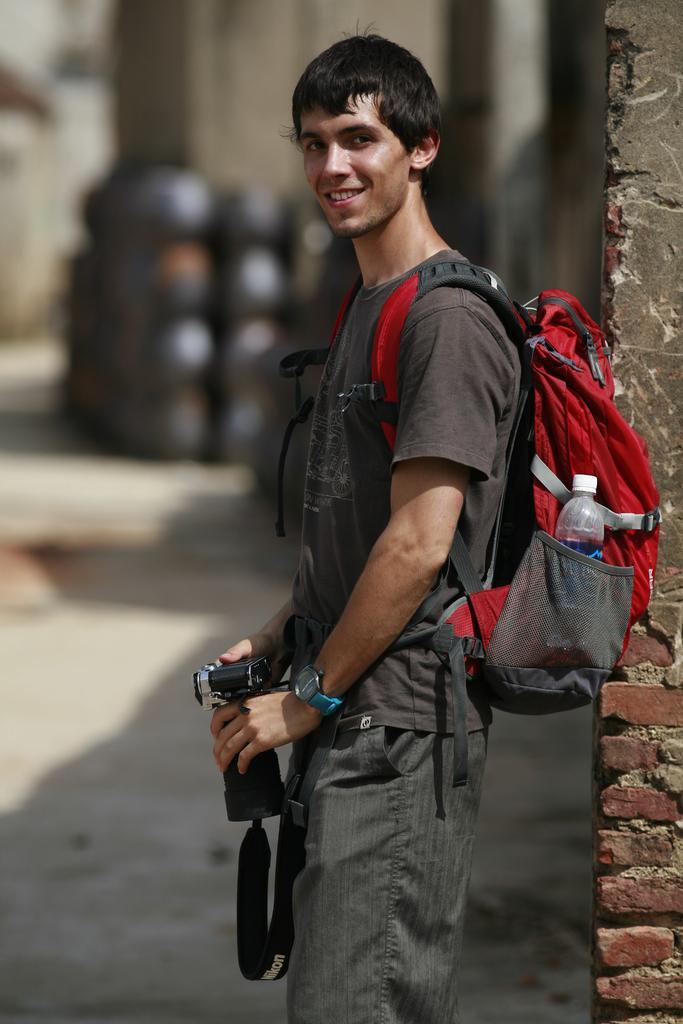Describe this image in one or two sentences. In this image there is one person who is standing and smiling, and he is wearing a bag and he is holding a camera. 